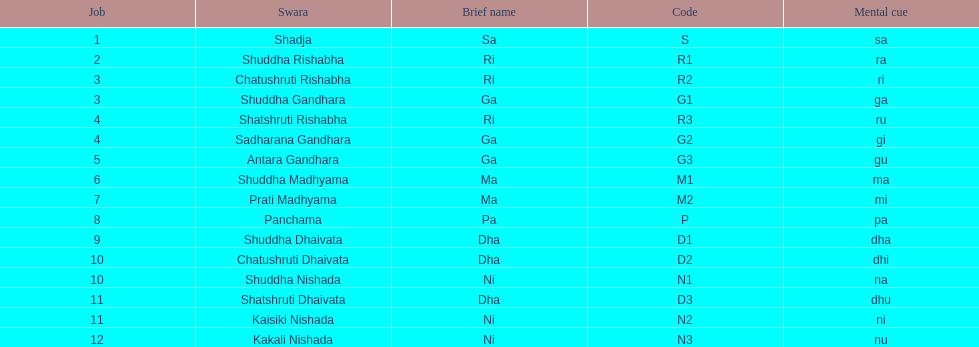Which swara follows immediately after antara gandhara? Shuddha Madhyama. 